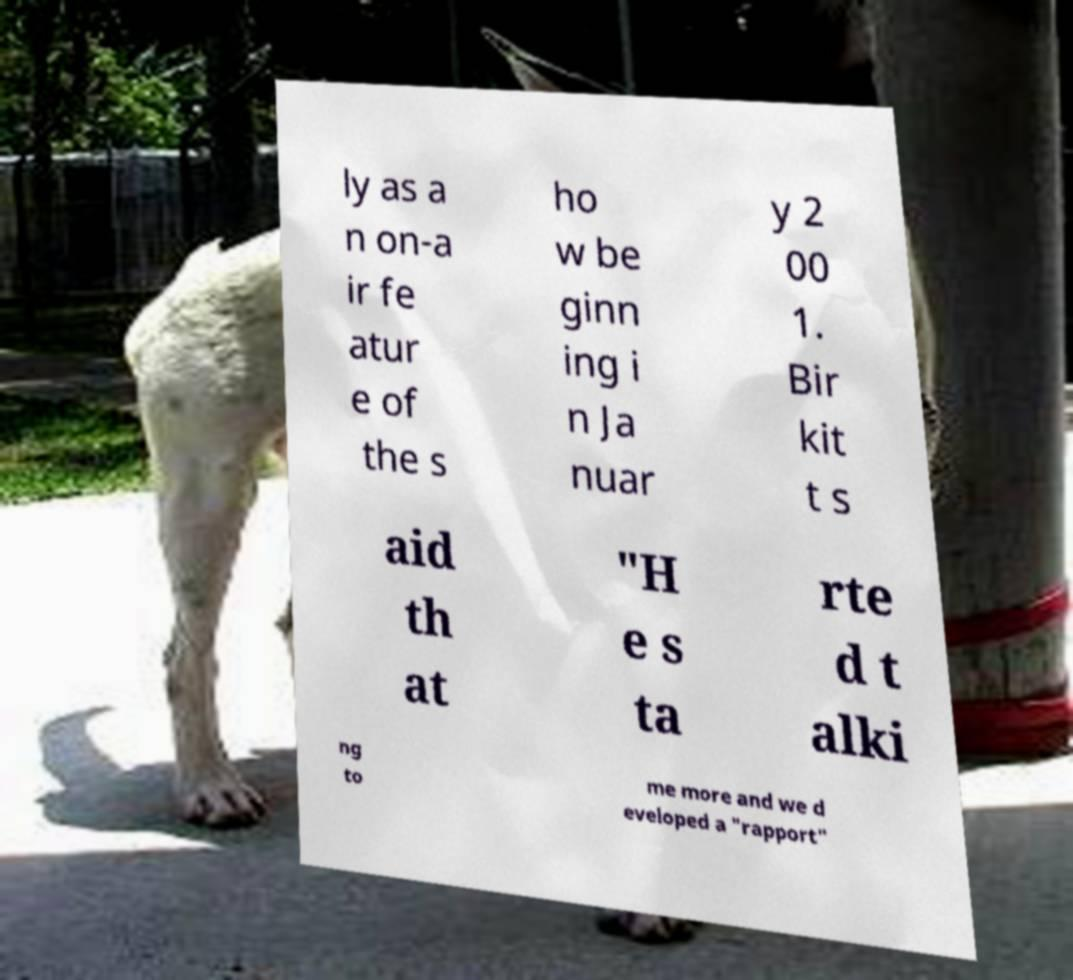Please identify and transcribe the text found in this image. ly as a n on-a ir fe atur e of the s ho w be ginn ing i n Ja nuar y 2 00 1. Bir kit t s aid th at "H e s ta rte d t alki ng to me more and we d eveloped a "rapport" 